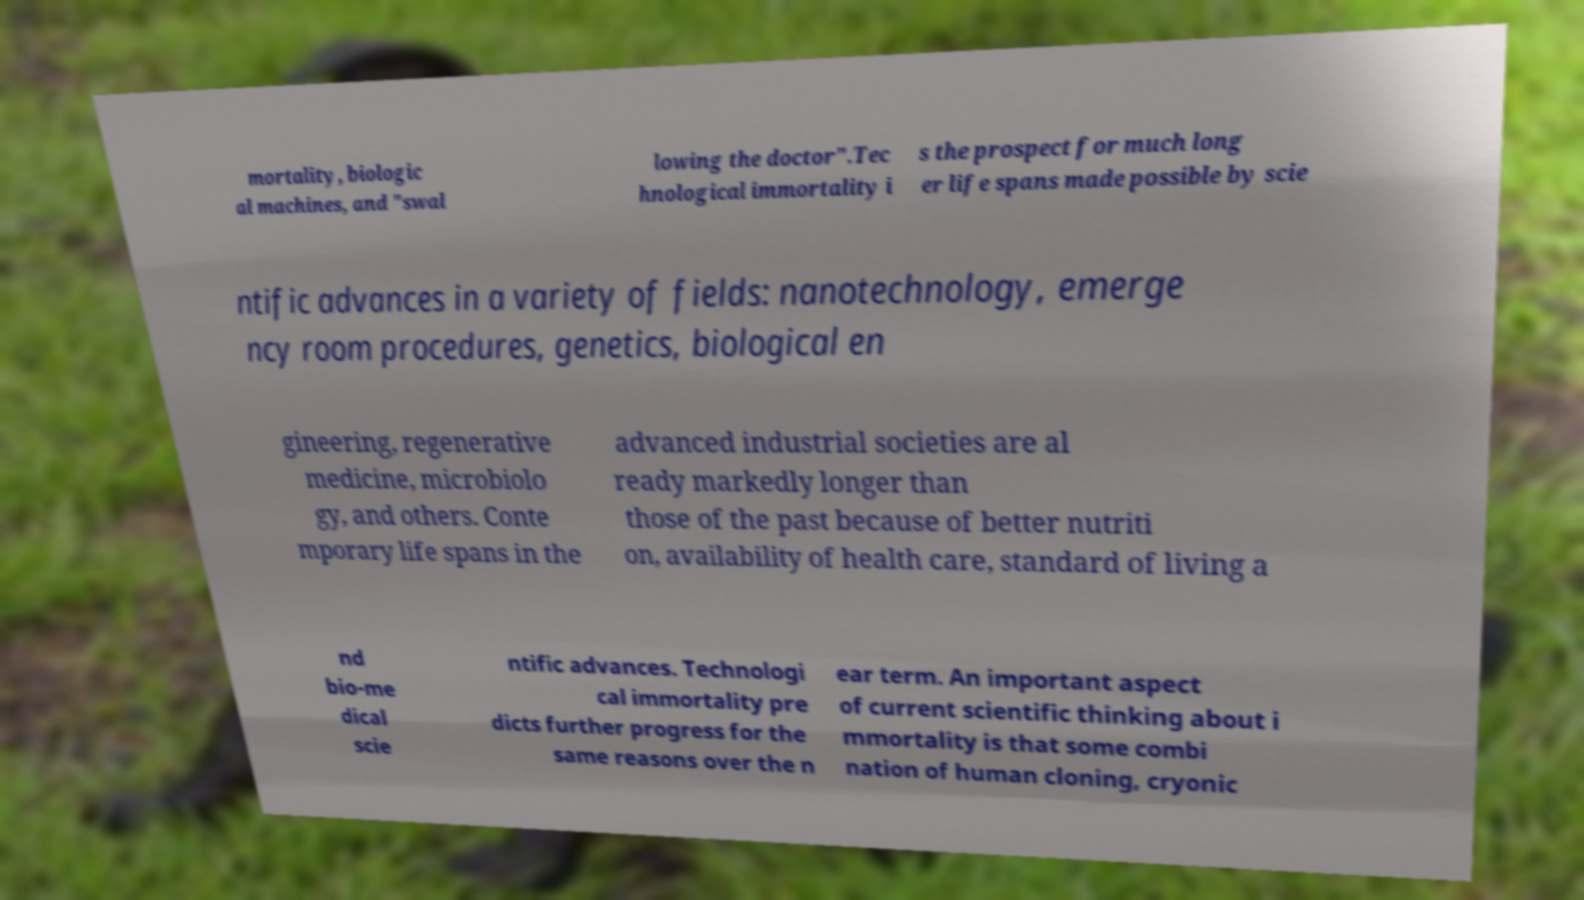For documentation purposes, I need the text within this image transcribed. Could you provide that? mortality, biologic al machines, and "swal lowing the doctor".Tec hnological immortality i s the prospect for much long er life spans made possible by scie ntific advances in a variety of fields: nanotechnology, emerge ncy room procedures, genetics, biological en gineering, regenerative medicine, microbiolo gy, and others. Conte mporary life spans in the advanced industrial societies are al ready markedly longer than those of the past because of better nutriti on, availability of health care, standard of living a nd bio-me dical scie ntific advances. Technologi cal immortality pre dicts further progress for the same reasons over the n ear term. An important aspect of current scientific thinking about i mmortality is that some combi nation of human cloning, cryonic 